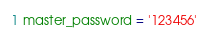Convert code to text. <code><loc_0><loc_0><loc_500><loc_500><_Python_>master_password = '123456'</code> 